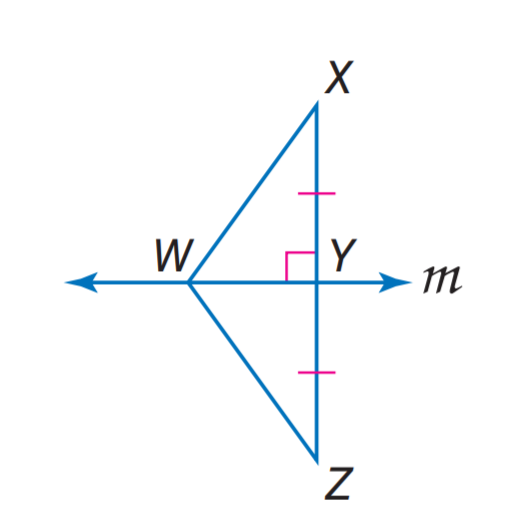Answer the mathemtical geometry problem and directly provide the correct option letter.
Question: m is the perpendicular bisector of X Z, W Z = 4 a - 15 and W Z = a + 12. Find W X.
Choices: A: 12 B: 15 C: 21 D: 22.4 C 